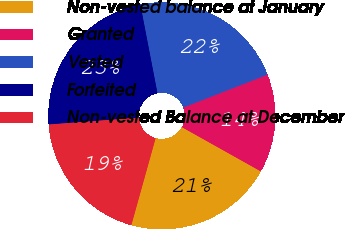<chart> <loc_0><loc_0><loc_500><loc_500><pie_chart><fcel>Non-vested balance at January<fcel>Granted<fcel>Vested<fcel>Forfeited<fcel>Non-vested Balance at December<nl><fcel>21.2%<fcel>14.05%<fcel>22.11%<fcel>23.19%<fcel>19.45%<nl></chart> 